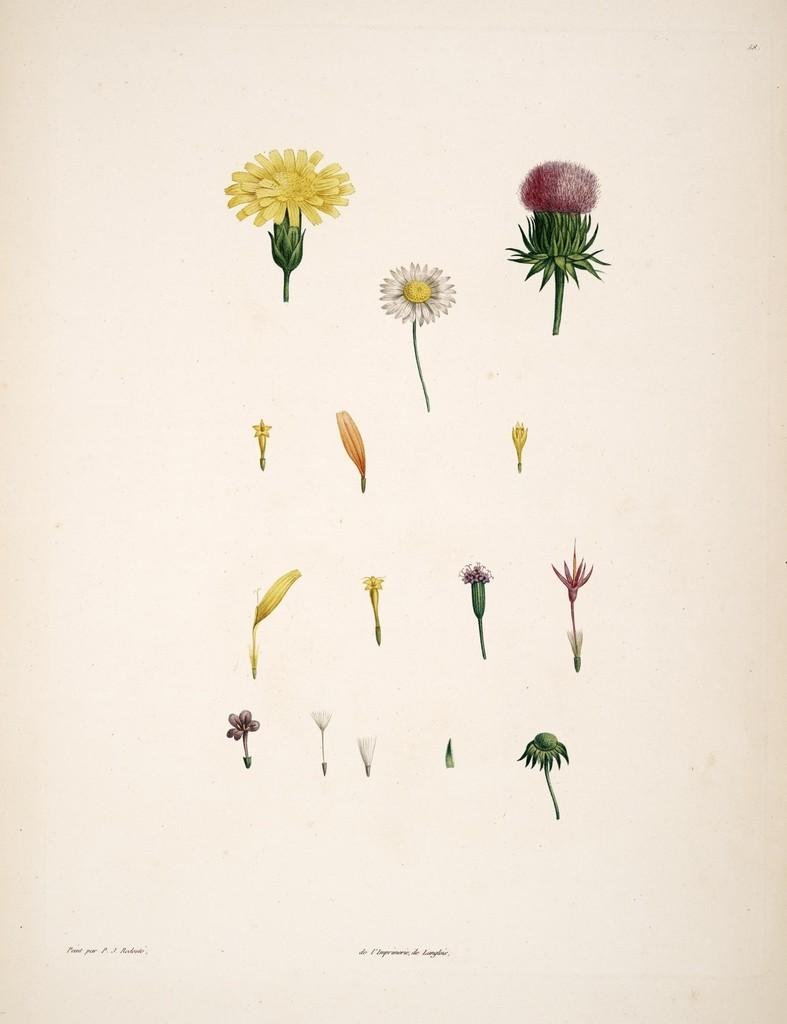What type of living organisms can be seen in the image? There are flowers in the image. What is the title of the book that is being read by the flowers in the image? There is no book or reading activity depicted in the image; it only features flowers. 